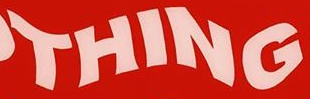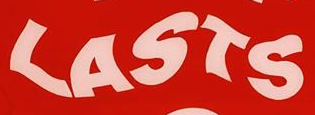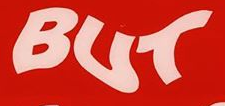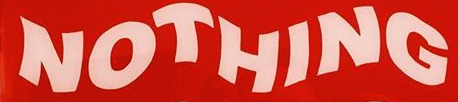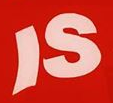What text is displayed in these images sequentially, separated by a semicolon? THING; LASTS; BUT; NOTHING; IS 